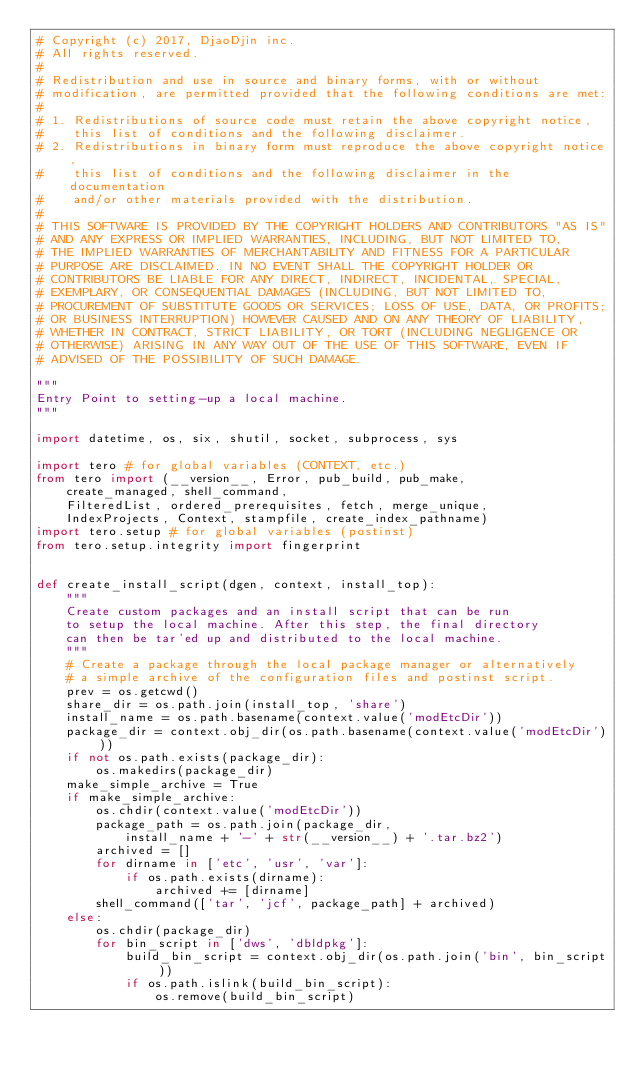<code> <loc_0><loc_0><loc_500><loc_500><_Python_># Copyright (c) 2017, DjaoDjin inc.
# All rights reserved.
#
# Redistribution and use in source and binary forms, with or without
# modification, are permitted provided that the following conditions are met:
#
# 1. Redistributions of source code must retain the above copyright notice,
#    this list of conditions and the following disclaimer.
# 2. Redistributions in binary form must reproduce the above copyright notice,
#    this list of conditions and the following disclaimer in the documentation
#    and/or other materials provided with the distribution.
#
# THIS SOFTWARE IS PROVIDED BY THE COPYRIGHT HOLDERS AND CONTRIBUTORS "AS IS"
# AND ANY EXPRESS OR IMPLIED WARRANTIES, INCLUDING, BUT NOT LIMITED TO,
# THE IMPLIED WARRANTIES OF MERCHANTABILITY AND FITNESS FOR A PARTICULAR
# PURPOSE ARE DISCLAIMED. IN NO EVENT SHALL THE COPYRIGHT HOLDER OR
# CONTRIBUTORS BE LIABLE FOR ANY DIRECT, INDIRECT, INCIDENTAL, SPECIAL,
# EXEMPLARY, OR CONSEQUENTIAL DAMAGES (INCLUDING, BUT NOT LIMITED TO,
# PROCUREMENT OF SUBSTITUTE GOODS OR SERVICES; LOSS OF USE, DATA, OR PROFITS;
# OR BUSINESS INTERRUPTION) HOWEVER CAUSED AND ON ANY THEORY OF LIABILITY,
# WHETHER IN CONTRACT, STRICT LIABILITY, OR TORT (INCLUDING NEGLIGENCE OR
# OTHERWISE) ARISING IN ANY WAY OUT OF THE USE OF THIS SOFTWARE, EVEN IF
# ADVISED OF THE POSSIBILITY OF SUCH DAMAGE.

"""
Entry Point to setting-up a local machine.
"""

import datetime, os, six, shutil, socket, subprocess, sys

import tero # for global variables (CONTEXT, etc.)
from tero import (__version__, Error, pub_build, pub_make,
    create_managed, shell_command,
    FilteredList, ordered_prerequisites, fetch, merge_unique,
    IndexProjects, Context, stampfile, create_index_pathname)
import tero.setup # for global variables (postinst)
from tero.setup.integrity import fingerprint


def create_install_script(dgen, context, install_top):
    """
    Create custom packages and an install script that can be run
    to setup the local machine. After this step, the final directory
    can then be tar'ed up and distributed to the local machine.
    """
    # Create a package through the local package manager or alternatively
    # a simple archive of the configuration files and postinst script.
    prev = os.getcwd()
    share_dir = os.path.join(install_top, 'share')
    install_name = os.path.basename(context.value('modEtcDir'))
    package_dir = context.obj_dir(os.path.basename(context.value('modEtcDir')))
    if not os.path.exists(package_dir):
        os.makedirs(package_dir)
    make_simple_archive = True
    if make_simple_archive:
        os.chdir(context.value('modEtcDir'))
        package_path = os.path.join(package_dir,
            install_name + '-' + str(__version__) + '.tar.bz2')
        archived = []
        for dirname in ['etc', 'usr', 'var']:
            if os.path.exists(dirname):
                archived += [dirname]
        shell_command(['tar', 'jcf', package_path] + archived)
    else:
        os.chdir(package_dir)
        for bin_script in ['dws', 'dbldpkg']:
            build_bin_script = context.obj_dir(os.path.join('bin', bin_script))
            if os.path.islink(build_bin_script):
                os.remove(build_bin_script)</code> 